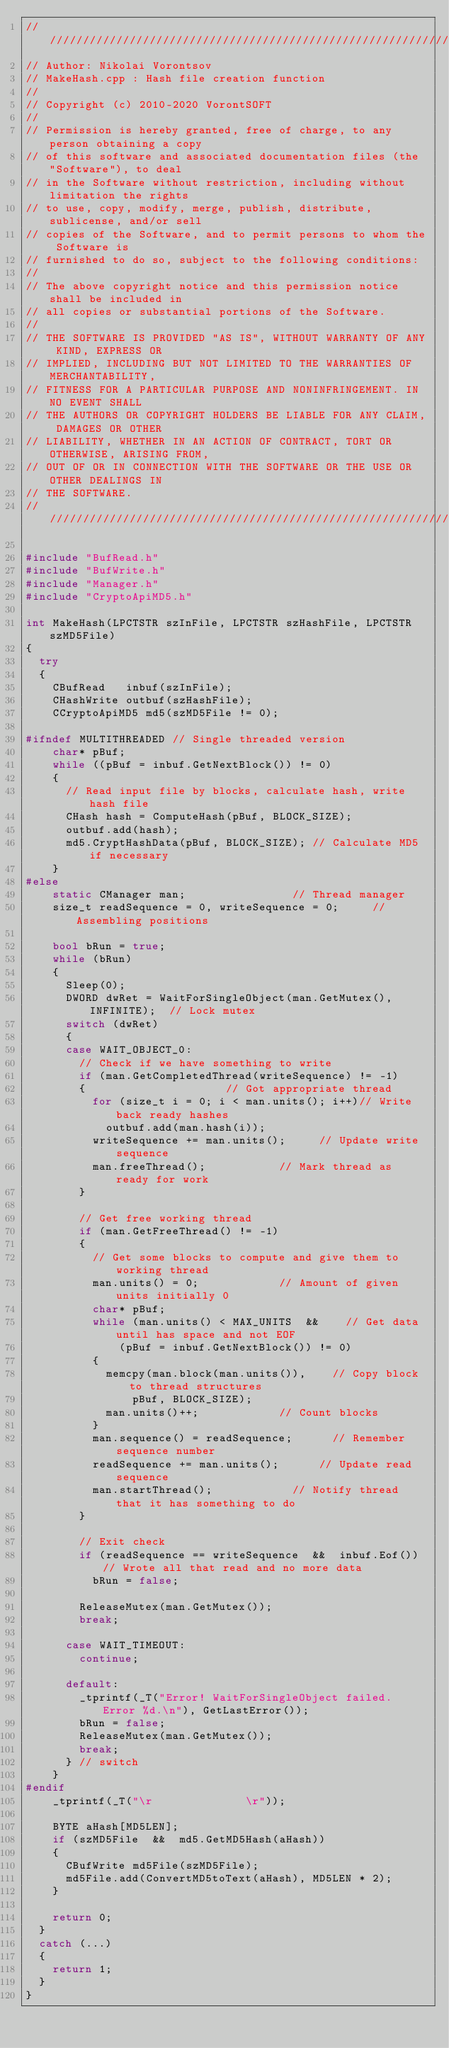Convert code to text. <code><loc_0><loc_0><loc_500><loc_500><_C++_>////////////////////////////////////////////////////////////////////////////////
// Author: Nikolai Vorontsov
// MakeHash.cpp : Hash file creation function
//
// Copyright (c) 2010-2020 VorontSOFT
//
// Permission is hereby granted, free of charge, to any person obtaining a copy
// of this software and associated documentation files (the "Software"), to deal
// in the Software without restriction, including without limitation the rights
// to use, copy, modify, merge, publish, distribute, sublicense, and/or sell 
// copies of the Software, and to permit persons to whom the Software is 
// furnished to do so, subject to the following conditions:
//
// The above copyright notice and this permission notice shall be included in 
// all copies or substantial portions of the Software.
//
// THE SOFTWARE IS PROVIDED "AS IS", WITHOUT WARRANTY OF ANY KIND, EXPRESS OR 
// IMPLIED, INCLUDING BUT NOT LIMITED TO THE WARRANTIES OF MERCHANTABILITY, 
// FITNESS FOR A PARTICULAR PURPOSE AND NONINFRINGEMENT. IN NO EVENT SHALL 
// THE AUTHORS OR COPYRIGHT HOLDERS BE LIABLE FOR ANY CLAIM, DAMAGES OR OTHER
// LIABILITY, WHETHER IN AN ACTION OF CONTRACT, TORT OR OTHERWISE, ARISING FROM,
// OUT OF OR IN CONNECTION WITH THE SOFTWARE OR THE USE OR OTHER DEALINGS IN 
// THE SOFTWARE.
////////////////////////////////////////////////////////////////////////////////

#include "BufRead.h"
#include "BufWrite.h"
#include "Manager.h"
#include "CryptoApiMD5.h"

int MakeHash(LPCTSTR szInFile, LPCTSTR szHashFile, LPCTSTR szMD5File)
{
	try
	{
		CBufRead   inbuf(szInFile);
		CHashWrite outbuf(szHashFile);
		CCryptoApiMD5 md5(szMD5File != 0);

#ifndef MULTITHREADED	// Single threaded version
		char* pBuf;
		while ((pBuf = inbuf.GetNextBlock()) != 0)
		{
			// Read input file by blocks, calculate hash, write hash file
			CHash hash = ComputeHash(pBuf, BLOCK_SIZE);
			outbuf.add(hash);
			md5.CryptHashData(pBuf, BLOCK_SIZE); // Calculate MD5 if necessary
		}
#else
		static CManager man;								// Thread manager
		size_t readSequence = 0, writeSequence = 0;			// Assembling positions

		bool bRun = true;
		while (bRun)
		{
			Sleep(0);
			DWORD dwRet = WaitForSingleObject(man.GetMutex(), INFINITE);	// Lock mutex
			switch (dwRet)
			{
			case WAIT_OBJECT_0:
				// Check if we have something to write
				if (man.GetCompletedThread(writeSequence) != -1)
				{											// Got appropriate thread
					for (size_t i = 0; i < man.units(); i++)// Write back ready hashes
						outbuf.add(man.hash(i));
					writeSequence += man.units();			// Update write sequence
					man.freeThread();						// Mark thread as ready for work
				}

				// Get free working thread
				if (man.GetFreeThread() != -1)
				{
					// Get some blocks to compute and give them to working thread
					man.units() = 0;						// Amount of given units initially 0
					char* pBuf;
					while (man.units() < MAX_UNITS  && 		// Get data until has space and not EOF
							(pBuf = inbuf.GetNextBlock()) != 0)
					{
						memcpy(man.block(man.units()),		// Copy block to thread structures
								pBuf, BLOCK_SIZE);
						man.units()++;						// Count blocks
					}
					man.sequence() = readSequence;			// Remember sequence number
					readSequence += man.units();			// Update read sequence
					man.startThread();						// Notify thread that it has something to do
				}

				// Exit check
				if (readSequence == writeSequence  &&  inbuf.Eof())	// Wrote all that read and no more data
					bRun = false;

				ReleaseMutex(man.GetMutex());
				break;

			case WAIT_TIMEOUT:
				continue;

			default:
				_tprintf(_T("Error! WaitForSingleObject failed. Error %d.\n"), GetLastError());
				bRun = false;
				ReleaseMutex(man.GetMutex());
				break;
			} // switch
		}
#endif
		_tprintf(_T("\r              \r"));

		BYTE aHash[MD5LEN];
		if (szMD5File  &&  md5.GetMD5Hash(aHash))
		{
			CBufWrite md5File(szMD5File);
			md5File.add(ConvertMD5toText(aHash), MD5LEN * 2);
		}

		return 0;
	}
	catch (...)
	{
		return 1;
	}
}
</code> 